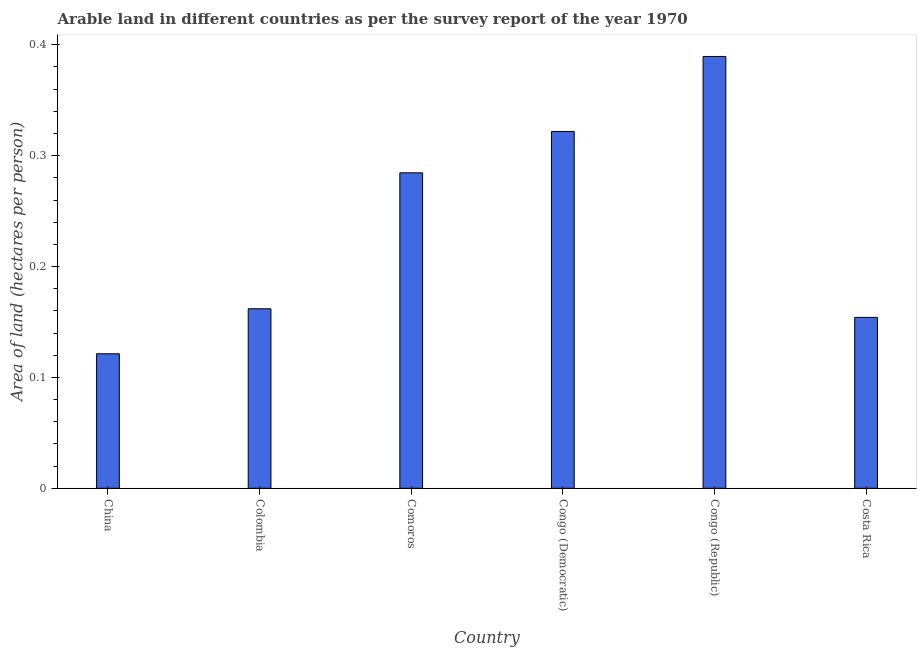Does the graph contain any zero values?
Offer a very short reply. No. What is the title of the graph?
Your response must be concise. Arable land in different countries as per the survey report of the year 1970. What is the label or title of the Y-axis?
Offer a very short reply. Area of land (hectares per person). What is the area of arable land in Congo (Democratic)?
Give a very brief answer. 0.32. Across all countries, what is the maximum area of arable land?
Make the answer very short. 0.39. Across all countries, what is the minimum area of arable land?
Your answer should be very brief. 0.12. In which country was the area of arable land maximum?
Give a very brief answer. Congo (Republic). What is the sum of the area of arable land?
Keep it short and to the point. 1.43. What is the difference between the area of arable land in Colombia and Congo (Democratic)?
Offer a very short reply. -0.16. What is the average area of arable land per country?
Provide a succinct answer. 0.24. What is the median area of arable land?
Your answer should be very brief. 0.22. What is the ratio of the area of arable land in Congo (Republic) to that in Costa Rica?
Keep it short and to the point. 2.53. Is the difference between the area of arable land in Colombia and Congo (Republic) greater than the difference between any two countries?
Offer a terse response. No. What is the difference between the highest and the second highest area of arable land?
Provide a succinct answer. 0.07. Is the sum of the area of arable land in Colombia and Costa Rica greater than the maximum area of arable land across all countries?
Your answer should be very brief. No. What is the difference between the highest and the lowest area of arable land?
Keep it short and to the point. 0.27. In how many countries, is the area of arable land greater than the average area of arable land taken over all countries?
Provide a succinct answer. 3. How many bars are there?
Your answer should be very brief. 6. Are all the bars in the graph horizontal?
Offer a terse response. No. How many countries are there in the graph?
Keep it short and to the point. 6. What is the difference between two consecutive major ticks on the Y-axis?
Give a very brief answer. 0.1. Are the values on the major ticks of Y-axis written in scientific E-notation?
Your answer should be compact. No. What is the Area of land (hectares per person) in China?
Keep it short and to the point. 0.12. What is the Area of land (hectares per person) in Colombia?
Offer a terse response. 0.16. What is the Area of land (hectares per person) of Comoros?
Your answer should be very brief. 0.28. What is the Area of land (hectares per person) of Congo (Democratic)?
Ensure brevity in your answer.  0.32. What is the Area of land (hectares per person) of Congo (Republic)?
Provide a short and direct response. 0.39. What is the Area of land (hectares per person) of Costa Rica?
Give a very brief answer. 0.15. What is the difference between the Area of land (hectares per person) in China and Colombia?
Offer a very short reply. -0.04. What is the difference between the Area of land (hectares per person) in China and Comoros?
Provide a succinct answer. -0.16. What is the difference between the Area of land (hectares per person) in China and Congo (Democratic)?
Give a very brief answer. -0.2. What is the difference between the Area of land (hectares per person) in China and Congo (Republic)?
Keep it short and to the point. -0.27. What is the difference between the Area of land (hectares per person) in China and Costa Rica?
Offer a very short reply. -0.03. What is the difference between the Area of land (hectares per person) in Colombia and Comoros?
Your answer should be compact. -0.12. What is the difference between the Area of land (hectares per person) in Colombia and Congo (Democratic)?
Your answer should be compact. -0.16. What is the difference between the Area of land (hectares per person) in Colombia and Congo (Republic)?
Offer a very short reply. -0.23. What is the difference between the Area of land (hectares per person) in Colombia and Costa Rica?
Make the answer very short. 0.01. What is the difference between the Area of land (hectares per person) in Comoros and Congo (Democratic)?
Your answer should be compact. -0.04. What is the difference between the Area of land (hectares per person) in Comoros and Congo (Republic)?
Ensure brevity in your answer.  -0.1. What is the difference between the Area of land (hectares per person) in Comoros and Costa Rica?
Offer a very short reply. 0.13. What is the difference between the Area of land (hectares per person) in Congo (Democratic) and Congo (Republic)?
Your response must be concise. -0.07. What is the difference between the Area of land (hectares per person) in Congo (Democratic) and Costa Rica?
Your response must be concise. 0.17. What is the difference between the Area of land (hectares per person) in Congo (Republic) and Costa Rica?
Provide a short and direct response. 0.24. What is the ratio of the Area of land (hectares per person) in China to that in Colombia?
Keep it short and to the point. 0.75. What is the ratio of the Area of land (hectares per person) in China to that in Comoros?
Offer a terse response. 0.43. What is the ratio of the Area of land (hectares per person) in China to that in Congo (Democratic)?
Offer a terse response. 0.38. What is the ratio of the Area of land (hectares per person) in China to that in Congo (Republic)?
Keep it short and to the point. 0.31. What is the ratio of the Area of land (hectares per person) in China to that in Costa Rica?
Your answer should be compact. 0.79. What is the ratio of the Area of land (hectares per person) in Colombia to that in Comoros?
Offer a very short reply. 0.57. What is the ratio of the Area of land (hectares per person) in Colombia to that in Congo (Democratic)?
Ensure brevity in your answer.  0.5. What is the ratio of the Area of land (hectares per person) in Colombia to that in Congo (Republic)?
Keep it short and to the point. 0.42. What is the ratio of the Area of land (hectares per person) in Comoros to that in Congo (Democratic)?
Your response must be concise. 0.88. What is the ratio of the Area of land (hectares per person) in Comoros to that in Congo (Republic)?
Your answer should be compact. 0.73. What is the ratio of the Area of land (hectares per person) in Comoros to that in Costa Rica?
Offer a terse response. 1.85. What is the ratio of the Area of land (hectares per person) in Congo (Democratic) to that in Congo (Republic)?
Your answer should be very brief. 0.83. What is the ratio of the Area of land (hectares per person) in Congo (Democratic) to that in Costa Rica?
Provide a succinct answer. 2.09. What is the ratio of the Area of land (hectares per person) in Congo (Republic) to that in Costa Rica?
Offer a very short reply. 2.53. 